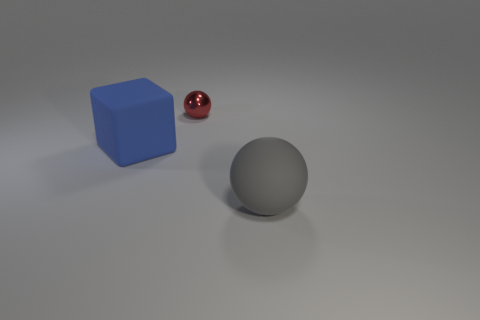Are there an equal number of big things to the right of the gray matte object and large blue things that are left of the small sphere?
Provide a short and direct response. No. Does the gray thing in front of the small red shiny thing have the same material as the thing left of the tiny object?
Make the answer very short. Yes. How many other objects are the same size as the red ball?
Give a very brief answer. 0. What number of objects are cubes or big things that are left of the red metal thing?
Keep it short and to the point. 1. Are there the same number of tiny metallic things that are in front of the big gray matte object and small metal cylinders?
Your answer should be compact. Yes. There is a large thing that is the same material as the large cube; what shape is it?
Your answer should be compact. Sphere. How many metal things are either blue cubes or tiny blue spheres?
Give a very brief answer. 0. What number of gray balls are behind the big gray rubber object to the right of the large blue thing?
Give a very brief answer. 0. How many large objects are the same material as the big gray sphere?
Provide a succinct answer. 1. How many small objects are either blue objects or yellow cylinders?
Your answer should be compact. 0. 